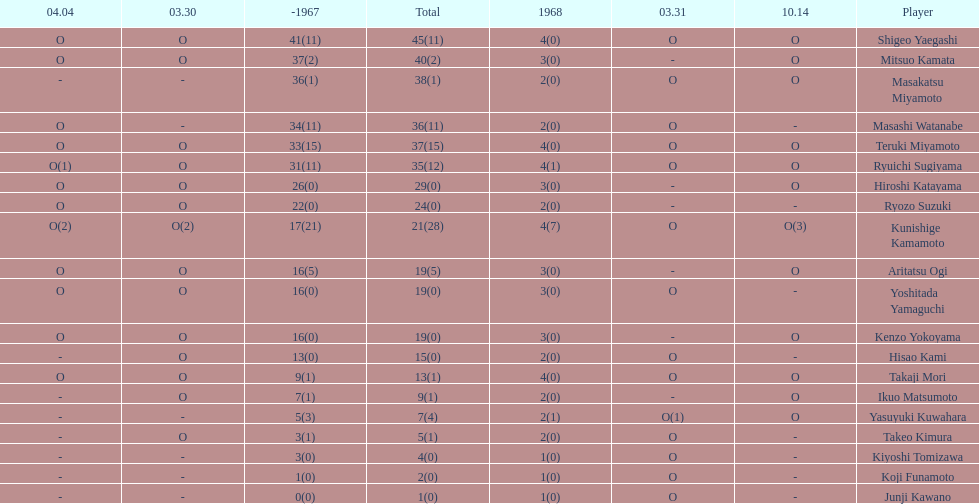How many total did mitsuo kamata have? 40(2). Help me parse the entirety of this table. {'header': ['04.04', '03.30', '-1967', 'Total', '1968', '03.31', '10.14', 'Player'], 'rows': [['O', 'O', '41(11)', '45(11)', '4(0)', 'O', 'O', 'Shigeo Yaegashi'], ['O', 'O', '37(2)', '40(2)', '3(0)', '-', 'O', 'Mitsuo Kamata'], ['-', '-', '36(1)', '38(1)', '2(0)', 'O', 'O', 'Masakatsu Miyamoto'], ['O', '-', '34(11)', '36(11)', '2(0)', 'O', '-', 'Masashi Watanabe'], ['O', 'O', '33(15)', '37(15)', '4(0)', 'O', 'O', 'Teruki Miyamoto'], ['O(1)', 'O', '31(11)', '35(12)', '4(1)', 'O', 'O', 'Ryuichi Sugiyama'], ['O', 'O', '26(0)', '29(0)', '3(0)', '-', 'O', 'Hiroshi Katayama'], ['O', 'O', '22(0)', '24(0)', '2(0)', '-', '-', 'Ryozo Suzuki'], ['O(2)', 'O(2)', '17(21)', '21(28)', '4(7)', 'O', 'O(3)', 'Kunishige Kamamoto'], ['O', 'O', '16(5)', '19(5)', '3(0)', '-', 'O', 'Aritatsu Ogi'], ['O', 'O', '16(0)', '19(0)', '3(0)', 'O', '-', 'Yoshitada Yamaguchi'], ['O', 'O', '16(0)', '19(0)', '3(0)', '-', 'O', 'Kenzo Yokoyama'], ['-', 'O', '13(0)', '15(0)', '2(0)', 'O', '-', 'Hisao Kami'], ['O', 'O', '9(1)', '13(1)', '4(0)', 'O', 'O', 'Takaji Mori'], ['-', 'O', '7(1)', '9(1)', '2(0)', '-', 'O', 'Ikuo Matsumoto'], ['-', '-', '5(3)', '7(4)', '2(1)', 'O(1)', 'O', 'Yasuyuki Kuwahara'], ['-', 'O', '3(1)', '5(1)', '2(0)', 'O', '-', 'Takeo Kimura'], ['-', '-', '3(0)', '4(0)', '1(0)', 'O', '-', 'Kiyoshi Tomizawa'], ['-', '-', '1(0)', '2(0)', '1(0)', 'O', '-', 'Koji Funamoto'], ['-', '-', '0(0)', '1(0)', '1(0)', 'O', '-', 'Junji Kawano']]} 